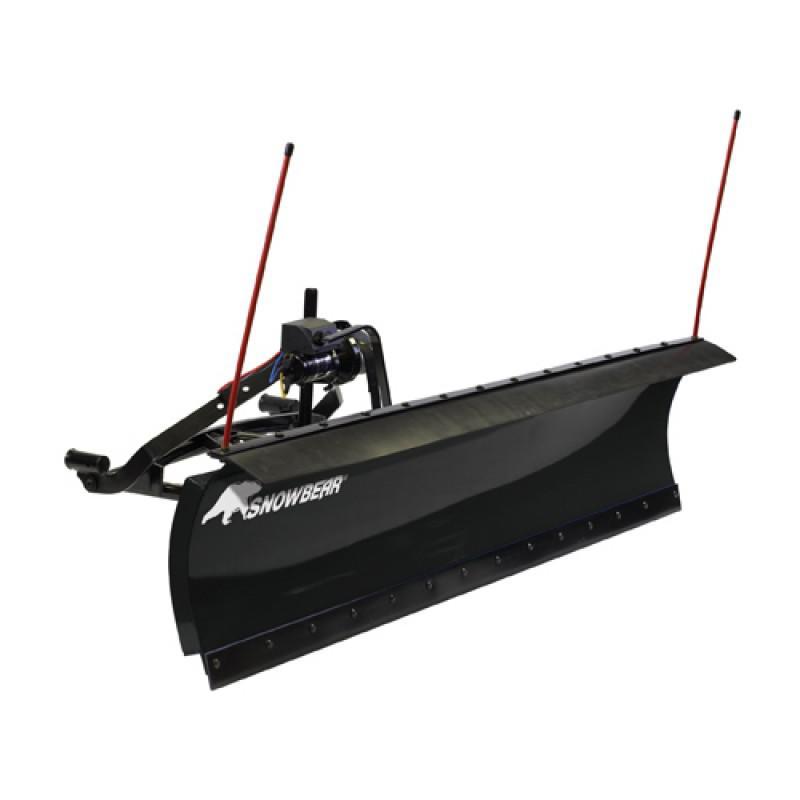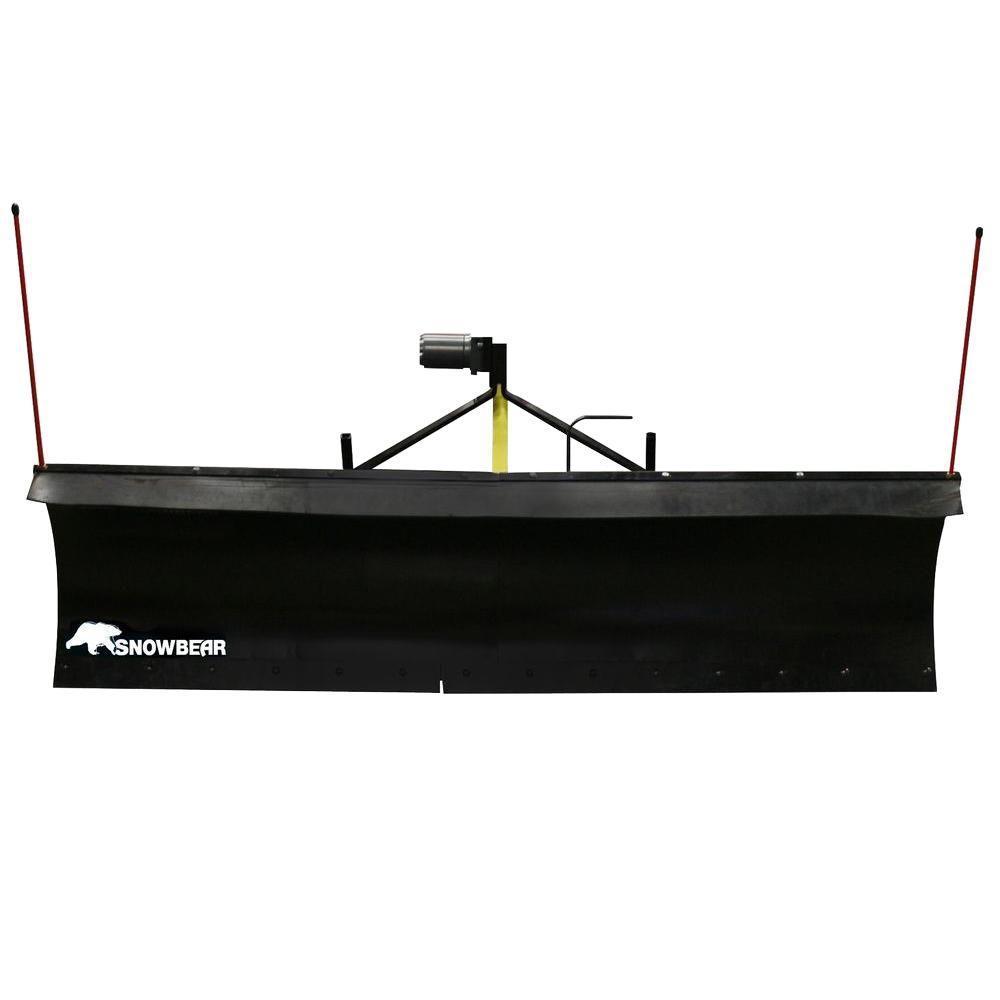The first image is the image on the left, the second image is the image on the right. Assess this claim about the two images: "An image shows a leftward-facing green tractor plowing snowy ground.". Correct or not? Answer yes or no. No. The first image is the image on the left, the second image is the image on the right. For the images displayed, is the sentence "In one image, a person wearing a coat and hat is plowing snow using a green tractor with yellow snow blade." factually correct? Answer yes or no. No. 